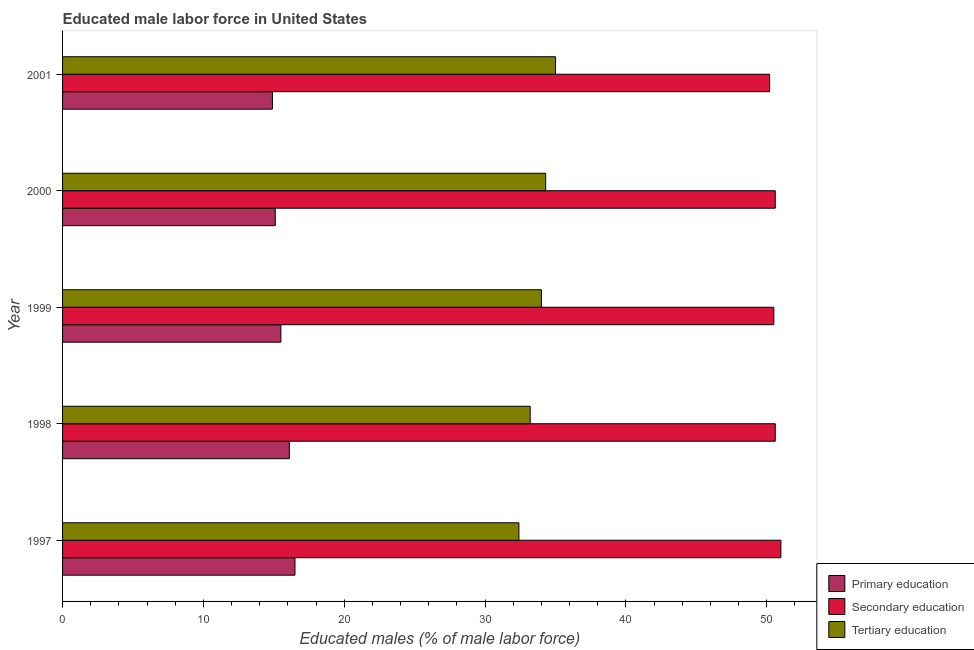How many groups of bars are there?
Provide a succinct answer. 5. Are the number of bars per tick equal to the number of legend labels?
Your answer should be compact. Yes. Are the number of bars on each tick of the Y-axis equal?
Offer a terse response. Yes. How many bars are there on the 5th tick from the top?
Give a very brief answer. 3. In how many cases, is the number of bars for a given year not equal to the number of legend labels?
Offer a very short reply. 0. What is the percentage of male labor force who received tertiary education in 2001?
Offer a terse response. 35. Across all years, what is the minimum percentage of male labor force who received primary education?
Offer a terse response. 14.9. In which year was the percentage of male labor force who received secondary education maximum?
Make the answer very short. 1997. What is the total percentage of male labor force who received primary education in the graph?
Offer a terse response. 78.1. What is the difference between the percentage of male labor force who received tertiary education in 1999 and the percentage of male labor force who received secondary education in 2001?
Your answer should be very brief. -16.2. What is the average percentage of male labor force who received secondary education per year?
Ensure brevity in your answer.  50.58. In the year 1999, what is the difference between the percentage of male labor force who received secondary education and percentage of male labor force who received tertiary education?
Your answer should be compact. 16.5. Is the percentage of male labor force who received primary education in 1999 less than that in 2000?
Give a very brief answer. No. What is the difference between the highest and the second highest percentage of male labor force who received secondary education?
Your answer should be compact. 0.4. What does the 1st bar from the top in 1999 represents?
Keep it short and to the point. Tertiary education. What does the 3rd bar from the bottom in 1999 represents?
Keep it short and to the point. Tertiary education. How many bars are there?
Offer a very short reply. 15. Are all the bars in the graph horizontal?
Provide a short and direct response. Yes. How many years are there in the graph?
Provide a succinct answer. 5. Are the values on the major ticks of X-axis written in scientific E-notation?
Provide a succinct answer. No. Where does the legend appear in the graph?
Your response must be concise. Bottom right. How many legend labels are there?
Provide a short and direct response. 3. How are the legend labels stacked?
Provide a short and direct response. Vertical. What is the title of the graph?
Your answer should be very brief. Educated male labor force in United States. Does "Argument" appear as one of the legend labels in the graph?
Your response must be concise. No. What is the label or title of the X-axis?
Ensure brevity in your answer.  Educated males (% of male labor force). What is the Educated males (% of male labor force) of Primary education in 1997?
Provide a succinct answer. 16.5. What is the Educated males (% of male labor force) of Secondary education in 1997?
Your response must be concise. 51. What is the Educated males (% of male labor force) in Tertiary education in 1997?
Provide a succinct answer. 32.4. What is the Educated males (% of male labor force) of Primary education in 1998?
Give a very brief answer. 16.1. What is the Educated males (% of male labor force) of Secondary education in 1998?
Offer a terse response. 50.6. What is the Educated males (% of male labor force) in Tertiary education in 1998?
Make the answer very short. 33.2. What is the Educated males (% of male labor force) in Primary education in 1999?
Your answer should be very brief. 15.5. What is the Educated males (% of male labor force) in Secondary education in 1999?
Your answer should be very brief. 50.5. What is the Educated males (% of male labor force) of Primary education in 2000?
Offer a terse response. 15.1. What is the Educated males (% of male labor force) in Secondary education in 2000?
Offer a terse response. 50.6. What is the Educated males (% of male labor force) in Tertiary education in 2000?
Provide a succinct answer. 34.3. What is the Educated males (% of male labor force) in Primary education in 2001?
Give a very brief answer. 14.9. What is the Educated males (% of male labor force) of Secondary education in 2001?
Ensure brevity in your answer.  50.2. What is the Educated males (% of male labor force) of Tertiary education in 2001?
Your answer should be compact. 35. Across all years, what is the maximum Educated males (% of male labor force) in Primary education?
Give a very brief answer. 16.5. Across all years, what is the maximum Educated males (% of male labor force) of Secondary education?
Offer a very short reply. 51. Across all years, what is the maximum Educated males (% of male labor force) of Tertiary education?
Your answer should be very brief. 35. Across all years, what is the minimum Educated males (% of male labor force) of Primary education?
Your answer should be very brief. 14.9. Across all years, what is the minimum Educated males (% of male labor force) in Secondary education?
Offer a terse response. 50.2. Across all years, what is the minimum Educated males (% of male labor force) of Tertiary education?
Offer a very short reply. 32.4. What is the total Educated males (% of male labor force) of Primary education in the graph?
Ensure brevity in your answer.  78.1. What is the total Educated males (% of male labor force) in Secondary education in the graph?
Provide a succinct answer. 252.9. What is the total Educated males (% of male labor force) of Tertiary education in the graph?
Make the answer very short. 168.9. What is the difference between the Educated males (% of male labor force) of Secondary education in 1997 and that in 1998?
Provide a succinct answer. 0.4. What is the difference between the Educated males (% of male labor force) of Tertiary education in 1997 and that in 1998?
Ensure brevity in your answer.  -0.8. What is the difference between the Educated males (% of male labor force) in Primary education in 1997 and that in 1999?
Provide a succinct answer. 1. What is the difference between the Educated males (% of male labor force) in Secondary education in 1997 and that in 1999?
Make the answer very short. 0.5. What is the difference between the Educated males (% of male labor force) in Tertiary education in 1997 and that in 1999?
Offer a terse response. -1.6. What is the difference between the Educated males (% of male labor force) of Primary education in 1997 and that in 2000?
Provide a short and direct response. 1.4. What is the difference between the Educated males (% of male labor force) of Secondary education in 1997 and that in 2000?
Keep it short and to the point. 0.4. What is the difference between the Educated males (% of male labor force) in Tertiary education in 1997 and that in 2000?
Your answer should be very brief. -1.9. What is the difference between the Educated males (% of male labor force) of Primary education in 1997 and that in 2001?
Your answer should be compact. 1.6. What is the difference between the Educated males (% of male labor force) in Secondary education in 1997 and that in 2001?
Your answer should be very brief. 0.8. What is the difference between the Educated males (% of male labor force) in Primary education in 1998 and that in 1999?
Provide a short and direct response. 0.6. What is the difference between the Educated males (% of male labor force) in Tertiary education in 1998 and that in 1999?
Offer a very short reply. -0.8. What is the difference between the Educated males (% of male labor force) of Tertiary education in 1998 and that in 2000?
Keep it short and to the point. -1.1. What is the difference between the Educated males (% of male labor force) of Secondary education in 1998 and that in 2001?
Give a very brief answer. 0.4. What is the difference between the Educated males (% of male labor force) of Tertiary education in 1998 and that in 2001?
Keep it short and to the point. -1.8. What is the difference between the Educated males (% of male labor force) in Primary education in 1999 and that in 2001?
Your response must be concise. 0.6. What is the difference between the Educated males (% of male labor force) of Primary education in 1997 and the Educated males (% of male labor force) of Secondary education in 1998?
Ensure brevity in your answer.  -34.1. What is the difference between the Educated males (% of male labor force) of Primary education in 1997 and the Educated males (% of male labor force) of Tertiary education in 1998?
Provide a succinct answer. -16.7. What is the difference between the Educated males (% of male labor force) of Primary education in 1997 and the Educated males (% of male labor force) of Secondary education in 1999?
Your answer should be compact. -34. What is the difference between the Educated males (% of male labor force) in Primary education in 1997 and the Educated males (% of male labor force) in Tertiary education in 1999?
Provide a succinct answer. -17.5. What is the difference between the Educated males (% of male labor force) of Secondary education in 1997 and the Educated males (% of male labor force) of Tertiary education in 1999?
Offer a very short reply. 17. What is the difference between the Educated males (% of male labor force) in Primary education in 1997 and the Educated males (% of male labor force) in Secondary education in 2000?
Offer a very short reply. -34.1. What is the difference between the Educated males (% of male labor force) in Primary education in 1997 and the Educated males (% of male labor force) in Tertiary education in 2000?
Provide a succinct answer. -17.8. What is the difference between the Educated males (% of male labor force) in Primary education in 1997 and the Educated males (% of male labor force) in Secondary education in 2001?
Your answer should be compact. -33.7. What is the difference between the Educated males (% of male labor force) of Primary education in 1997 and the Educated males (% of male labor force) of Tertiary education in 2001?
Make the answer very short. -18.5. What is the difference between the Educated males (% of male labor force) of Primary education in 1998 and the Educated males (% of male labor force) of Secondary education in 1999?
Your response must be concise. -34.4. What is the difference between the Educated males (% of male labor force) of Primary education in 1998 and the Educated males (% of male labor force) of Tertiary education in 1999?
Offer a very short reply. -17.9. What is the difference between the Educated males (% of male labor force) in Secondary education in 1998 and the Educated males (% of male labor force) in Tertiary education in 1999?
Keep it short and to the point. 16.6. What is the difference between the Educated males (% of male labor force) in Primary education in 1998 and the Educated males (% of male labor force) in Secondary education in 2000?
Give a very brief answer. -34.5. What is the difference between the Educated males (% of male labor force) in Primary education in 1998 and the Educated males (% of male labor force) in Tertiary education in 2000?
Offer a very short reply. -18.2. What is the difference between the Educated males (% of male labor force) of Primary education in 1998 and the Educated males (% of male labor force) of Secondary education in 2001?
Keep it short and to the point. -34.1. What is the difference between the Educated males (% of male labor force) of Primary education in 1998 and the Educated males (% of male labor force) of Tertiary education in 2001?
Your response must be concise. -18.9. What is the difference between the Educated males (% of male labor force) of Secondary education in 1998 and the Educated males (% of male labor force) of Tertiary education in 2001?
Your answer should be compact. 15.6. What is the difference between the Educated males (% of male labor force) in Primary education in 1999 and the Educated males (% of male labor force) in Secondary education in 2000?
Your answer should be very brief. -35.1. What is the difference between the Educated males (% of male labor force) of Primary education in 1999 and the Educated males (% of male labor force) of Tertiary education in 2000?
Give a very brief answer. -18.8. What is the difference between the Educated males (% of male labor force) of Primary education in 1999 and the Educated males (% of male labor force) of Secondary education in 2001?
Provide a short and direct response. -34.7. What is the difference between the Educated males (% of male labor force) of Primary education in 1999 and the Educated males (% of male labor force) of Tertiary education in 2001?
Ensure brevity in your answer.  -19.5. What is the difference between the Educated males (% of male labor force) in Secondary education in 1999 and the Educated males (% of male labor force) in Tertiary education in 2001?
Provide a short and direct response. 15.5. What is the difference between the Educated males (% of male labor force) in Primary education in 2000 and the Educated males (% of male labor force) in Secondary education in 2001?
Provide a short and direct response. -35.1. What is the difference between the Educated males (% of male labor force) of Primary education in 2000 and the Educated males (% of male labor force) of Tertiary education in 2001?
Ensure brevity in your answer.  -19.9. What is the average Educated males (% of male labor force) in Primary education per year?
Offer a very short reply. 15.62. What is the average Educated males (% of male labor force) in Secondary education per year?
Offer a very short reply. 50.58. What is the average Educated males (% of male labor force) in Tertiary education per year?
Keep it short and to the point. 33.78. In the year 1997, what is the difference between the Educated males (% of male labor force) in Primary education and Educated males (% of male labor force) in Secondary education?
Provide a short and direct response. -34.5. In the year 1997, what is the difference between the Educated males (% of male labor force) in Primary education and Educated males (% of male labor force) in Tertiary education?
Your response must be concise. -15.9. In the year 1998, what is the difference between the Educated males (% of male labor force) in Primary education and Educated males (% of male labor force) in Secondary education?
Your answer should be compact. -34.5. In the year 1998, what is the difference between the Educated males (% of male labor force) in Primary education and Educated males (% of male labor force) in Tertiary education?
Your answer should be compact. -17.1. In the year 1998, what is the difference between the Educated males (% of male labor force) of Secondary education and Educated males (% of male labor force) of Tertiary education?
Offer a very short reply. 17.4. In the year 1999, what is the difference between the Educated males (% of male labor force) in Primary education and Educated males (% of male labor force) in Secondary education?
Give a very brief answer. -35. In the year 1999, what is the difference between the Educated males (% of male labor force) of Primary education and Educated males (% of male labor force) of Tertiary education?
Keep it short and to the point. -18.5. In the year 2000, what is the difference between the Educated males (% of male labor force) in Primary education and Educated males (% of male labor force) in Secondary education?
Your response must be concise. -35.5. In the year 2000, what is the difference between the Educated males (% of male labor force) in Primary education and Educated males (% of male labor force) in Tertiary education?
Keep it short and to the point. -19.2. In the year 2001, what is the difference between the Educated males (% of male labor force) in Primary education and Educated males (% of male labor force) in Secondary education?
Your response must be concise. -35.3. In the year 2001, what is the difference between the Educated males (% of male labor force) in Primary education and Educated males (% of male labor force) in Tertiary education?
Give a very brief answer. -20.1. What is the ratio of the Educated males (% of male labor force) of Primary education in 1997 to that in 1998?
Give a very brief answer. 1.02. What is the ratio of the Educated males (% of male labor force) of Secondary education in 1997 to that in 1998?
Make the answer very short. 1.01. What is the ratio of the Educated males (% of male labor force) in Tertiary education in 1997 to that in 1998?
Ensure brevity in your answer.  0.98. What is the ratio of the Educated males (% of male labor force) in Primary education in 1997 to that in 1999?
Your response must be concise. 1.06. What is the ratio of the Educated males (% of male labor force) in Secondary education in 1997 to that in 1999?
Offer a very short reply. 1.01. What is the ratio of the Educated males (% of male labor force) in Tertiary education in 1997 to that in 1999?
Ensure brevity in your answer.  0.95. What is the ratio of the Educated males (% of male labor force) of Primary education in 1997 to that in 2000?
Provide a short and direct response. 1.09. What is the ratio of the Educated males (% of male labor force) in Secondary education in 1997 to that in 2000?
Ensure brevity in your answer.  1.01. What is the ratio of the Educated males (% of male labor force) of Tertiary education in 1997 to that in 2000?
Provide a succinct answer. 0.94. What is the ratio of the Educated males (% of male labor force) in Primary education in 1997 to that in 2001?
Your response must be concise. 1.11. What is the ratio of the Educated males (% of male labor force) in Secondary education in 1997 to that in 2001?
Your response must be concise. 1.02. What is the ratio of the Educated males (% of male labor force) of Tertiary education in 1997 to that in 2001?
Provide a short and direct response. 0.93. What is the ratio of the Educated males (% of male labor force) of Primary education in 1998 to that in 1999?
Your answer should be compact. 1.04. What is the ratio of the Educated males (% of male labor force) of Secondary education in 1998 to that in 1999?
Give a very brief answer. 1. What is the ratio of the Educated males (% of male labor force) in Tertiary education in 1998 to that in 1999?
Give a very brief answer. 0.98. What is the ratio of the Educated males (% of male labor force) of Primary education in 1998 to that in 2000?
Your answer should be compact. 1.07. What is the ratio of the Educated males (% of male labor force) in Tertiary education in 1998 to that in 2000?
Keep it short and to the point. 0.97. What is the ratio of the Educated males (% of male labor force) in Primary education in 1998 to that in 2001?
Keep it short and to the point. 1.08. What is the ratio of the Educated males (% of male labor force) in Secondary education in 1998 to that in 2001?
Offer a very short reply. 1.01. What is the ratio of the Educated males (% of male labor force) of Tertiary education in 1998 to that in 2001?
Your answer should be very brief. 0.95. What is the ratio of the Educated males (% of male labor force) in Primary education in 1999 to that in 2000?
Offer a very short reply. 1.03. What is the ratio of the Educated males (% of male labor force) of Tertiary education in 1999 to that in 2000?
Keep it short and to the point. 0.99. What is the ratio of the Educated males (% of male labor force) of Primary education in 1999 to that in 2001?
Provide a succinct answer. 1.04. What is the ratio of the Educated males (% of male labor force) of Secondary education in 1999 to that in 2001?
Make the answer very short. 1.01. What is the ratio of the Educated males (% of male labor force) of Tertiary education in 1999 to that in 2001?
Ensure brevity in your answer.  0.97. What is the ratio of the Educated males (% of male labor force) of Primary education in 2000 to that in 2001?
Your answer should be compact. 1.01. What is the ratio of the Educated males (% of male labor force) of Secondary education in 2000 to that in 2001?
Offer a very short reply. 1.01. What is the ratio of the Educated males (% of male labor force) of Tertiary education in 2000 to that in 2001?
Offer a terse response. 0.98. What is the difference between the highest and the second highest Educated males (% of male labor force) of Secondary education?
Keep it short and to the point. 0.4. What is the difference between the highest and the lowest Educated males (% of male labor force) of Primary education?
Offer a very short reply. 1.6. 